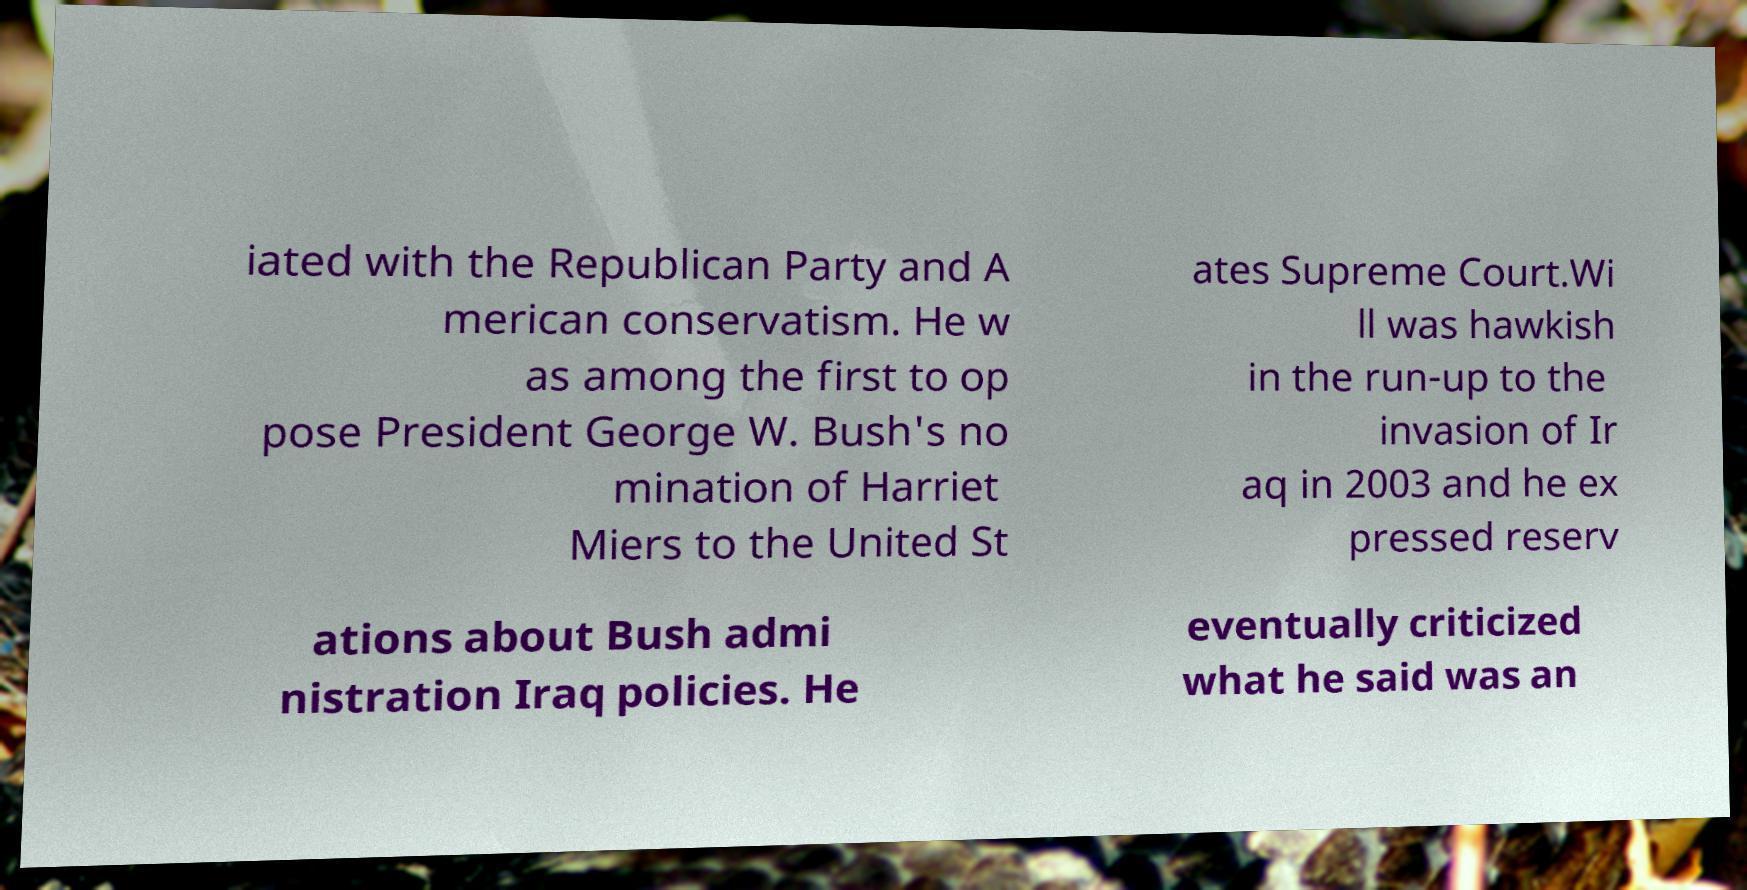Can you read and provide the text displayed in the image?This photo seems to have some interesting text. Can you extract and type it out for me? iated with the Republican Party and A merican conservatism. He w as among the first to op pose President George W. Bush's no mination of Harriet Miers to the United St ates Supreme Court.Wi ll was hawkish in the run-up to the invasion of Ir aq in 2003 and he ex pressed reserv ations about Bush admi nistration Iraq policies. He eventually criticized what he said was an 